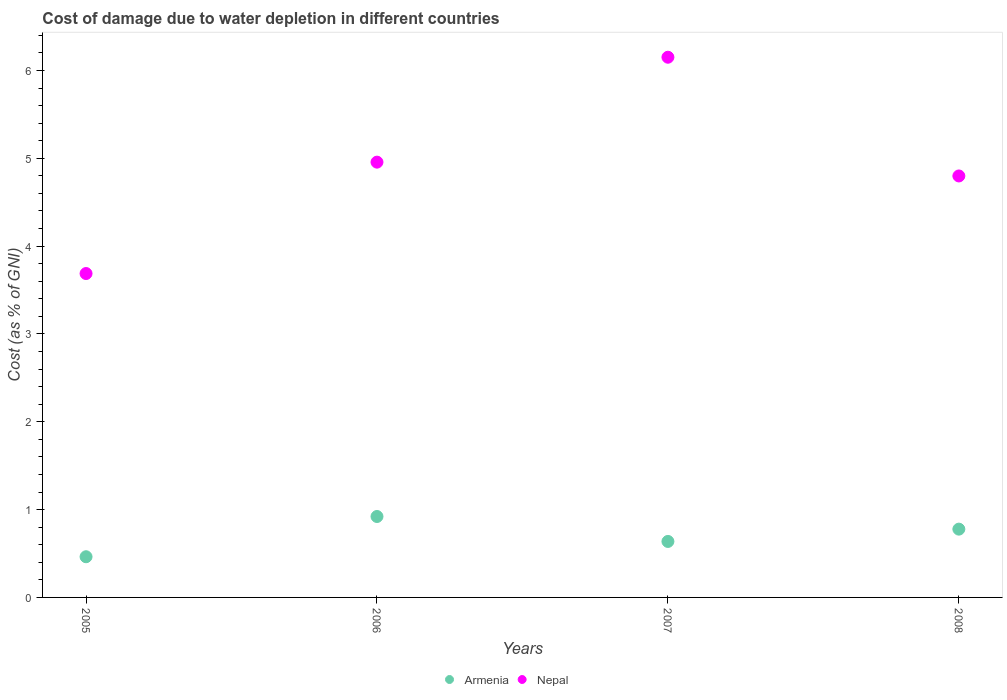Is the number of dotlines equal to the number of legend labels?
Ensure brevity in your answer.  Yes. What is the cost of damage caused due to water depletion in Nepal in 2007?
Your answer should be very brief. 6.15. Across all years, what is the maximum cost of damage caused due to water depletion in Nepal?
Make the answer very short. 6.15. Across all years, what is the minimum cost of damage caused due to water depletion in Nepal?
Your response must be concise. 3.69. What is the total cost of damage caused due to water depletion in Nepal in the graph?
Give a very brief answer. 19.59. What is the difference between the cost of damage caused due to water depletion in Armenia in 2007 and that in 2008?
Keep it short and to the point. -0.14. What is the difference between the cost of damage caused due to water depletion in Armenia in 2006 and the cost of damage caused due to water depletion in Nepal in 2007?
Your response must be concise. -5.23. What is the average cost of damage caused due to water depletion in Armenia per year?
Your response must be concise. 0.7. In the year 2005, what is the difference between the cost of damage caused due to water depletion in Nepal and cost of damage caused due to water depletion in Armenia?
Your answer should be compact. 3.22. What is the ratio of the cost of damage caused due to water depletion in Armenia in 2005 to that in 2006?
Ensure brevity in your answer.  0.5. What is the difference between the highest and the second highest cost of damage caused due to water depletion in Armenia?
Your answer should be very brief. 0.14. What is the difference between the highest and the lowest cost of damage caused due to water depletion in Nepal?
Keep it short and to the point. 2.46. Is the sum of the cost of damage caused due to water depletion in Armenia in 2007 and 2008 greater than the maximum cost of damage caused due to water depletion in Nepal across all years?
Offer a very short reply. No. Is the cost of damage caused due to water depletion in Nepal strictly greater than the cost of damage caused due to water depletion in Armenia over the years?
Provide a succinct answer. Yes. How many dotlines are there?
Offer a terse response. 2. Are the values on the major ticks of Y-axis written in scientific E-notation?
Keep it short and to the point. No. Does the graph contain grids?
Your response must be concise. No. Where does the legend appear in the graph?
Give a very brief answer. Bottom center. How many legend labels are there?
Ensure brevity in your answer.  2. What is the title of the graph?
Make the answer very short. Cost of damage due to water depletion in different countries. Does "Mali" appear as one of the legend labels in the graph?
Offer a terse response. No. What is the label or title of the Y-axis?
Your answer should be very brief. Cost (as % of GNI). What is the Cost (as % of GNI) of Armenia in 2005?
Your response must be concise. 0.46. What is the Cost (as % of GNI) of Nepal in 2005?
Ensure brevity in your answer.  3.69. What is the Cost (as % of GNI) of Armenia in 2006?
Keep it short and to the point. 0.92. What is the Cost (as % of GNI) in Nepal in 2006?
Your answer should be compact. 4.96. What is the Cost (as % of GNI) of Armenia in 2007?
Keep it short and to the point. 0.64. What is the Cost (as % of GNI) in Nepal in 2007?
Provide a short and direct response. 6.15. What is the Cost (as % of GNI) of Armenia in 2008?
Your answer should be compact. 0.78. What is the Cost (as % of GNI) in Nepal in 2008?
Keep it short and to the point. 4.8. Across all years, what is the maximum Cost (as % of GNI) of Armenia?
Your answer should be compact. 0.92. Across all years, what is the maximum Cost (as % of GNI) of Nepal?
Make the answer very short. 6.15. Across all years, what is the minimum Cost (as % of GNI) in Armenia?
Keep it short and to the point. 0.46. Across all years, what is the minimum Cost (as % of GNI) of Nepal?
Ensure brevity in your answer.  3.69. What is the total Cost (as % of GNI) in Armenia in the graph?
Ensure brevity in your answer.  2.8. What is the total Cost (as % of GNI) of Nepal in the graph?
Keep it short and to the point. 19.59. What is the difference between the Cost (as % of GNI) in Armenia in 2005 and that in 2006?
Your answer should be compact. -0.46. What is the difference between the Cost (as % of GNI) of Nepal in 2005 and that in 2006?
Your answer should be compact. -1.27. What is the difference between the Cost (as % of GNI) in Armenia in 2005 and that in 2007?
Your answer should be very brief. -0.17. What is the difference between the Cost (as % of GNI) of Nepal in 2005 and that in 2007?
Keep it short and to the point. -2.46. What is the difference between the Cost (as % of GNI) in Armenia in 2005 and that in 2008?
Ensure brevity in your answer.  -0.31. What is the difference between the Cost (as % of GNI) in Nepal in 2005 and that in 2008?
Your answer should be compact. -1.11. What is the difference between the Cost (as % of GNI) of Armenia in 2006 and that in 2007?
Your response must be concise. 0.28. What is the difference between the Cost (as % of GNI) of Nepal in 2006 and that in 2007?
Offer a very short reply. -1.19. What is the difference between the Cost (as % of GNI) of Armenia in 2006 and that in 2008?
Make the answer very short. 0.14. What is the difference between the Cost (as % of GNI) of Nepal in 2006 and that in 2008?
Ensure brevity in your answer.  0.16. What is the difference between the Cost (as % of GNI) of Armenia in 2007 and that in 2008?
Offer a very short reply. -0.14. What is the difference between the Cost (as % of GNI) of Nepal in 2007 and that in 2008?
Provide a succinct answer. 1.35. What is the difference between the Cost (as % of GNI) in Armenia in 2005 and the Cost (as % of GNI) in Nepal in 2006?
Your answer should be compact. -4.49. What is the difference between the Cost (as % of GNI) in Armenia in 2005 and the Cost (as % of GNI) in Nepal in 2007?
Provide a succinct answer. -5.69. What is the difference between the Cost (as % of GNI) in Armenia in 2005 and the Cost (as % of GNI) in Nepal in 2008?
Give a very brief answer. -4.34. What is the difference between the Cost (as % of GNI) of Armenia in 2006 and the Cost (as % of GNI) of Nepal in 2007?
Provide a succinct answer. -5.23. What is the difference between the Cost (as % of GNI) in Armenia in 2006 and the Cost (as % of GNI) in Nepal in 2008?
Make the answer very short. -3.88. What is the difference between the Cost (as % of GNI) in Armenia in 2007 and the Cost (as % of GNI) in Nepal in 2008?
Offer a terse response. -4.16. What is the average Cost (as % of GNI) of Armenia per year?
Offer a very short reply. 0.7. What is the average Cost (as % of GNI) of Nepal per year?
Offer a terse response. 4.9. In the year 2005, what is the difference between the Cost (as % of GNI) of Armenia and Cost (as % of GNI) of Nepal?
Make the answer very short. -3.22. In the year 2006, what is the difference between the Cost (as % of GNI) in Armenia and Cost (as % of GNI) in Nepal?
Keep it short and to the point. -4.03. In the year 2007, what is the difference between the Cost (as % of GNI) of Armenia and Cost (as % of GNI) of Nepal?
Ensure brevity in your answer.  -5.51. In the year 2008, what is the difference between the Cost (as % of GNI) in Armenia and Cost (as % of GNI) in Nepal?
Offer a terse response. -4.02. What is the ratio of the Cost (as % of GNI) in Armenia in 2005 to that in 2006?
Provide a succinct answer. 0.5. What is the ratio of the Cost (as % of GNI) of Nepal in 2005 to that in 2006?
Your answer should be very brief. 0.74. What is the ratio of the Cost (as % of GNI) of Armenia in 2005 to that in 2007?
Your answer should be compact. 0.73. What is the ratio of the Cost (as % of GNI) in Nepal in 2005 to that in 2007?
Your response must be concise. 0.6. What is the ratio of the Cost (as % of GNI) of Armenia in 2005 to that in 2008?
Give a very brief answer. 0.6. What is the ratio of the Cost (as % of GNI) in Nepal in 2005 to that in 2008?
Keep it short and to the point. 0.77. What is the ratio of the Cost (as % of GNI) in Armenia in 2006 to that in 2007?
Make the answer very short. 1.45. What is the ratio of the Cost (as % of GNI) of Nepal in 2006 to that in 2007?
Your response must be concise. 0.81. What is the ratio of the Cost (as % of GNI) of Armenia in 2006 to that in 2008?
Offer a terse response. 1.19. What is the ratio of the Cost (as % of GNI) in Nepal in 2006 to that in 2008?
Keep it short and to the point. 1.03. What is the ratio of the Cost (as % of GNI) of Armenia in 2007 to that in 2008?
Your answer should be very brief. 0.82. What is the ratio of the Cost (as % of GNI) in Nepal in 2007 to that in 2008?
Ensure brevity in your answer.  1.28. What is the difference between the highest and the second highest Cost (as % of GNI) in Armenia?
Your answer should be very brief. 0.14. What is the difference between the highest and the second highest Cost (as % of GNI) of Nepal?
Ensure brevity in your answer.  1.19. What is the difference between the highest and the lowest Cost (as % of GNI) in Armenia?
Provide a short and direct response. 0.46. What is the difference between the highest and the lowest Cost (as % of GNI) of Nepal?
Provide a succinct answer. 2.46. 